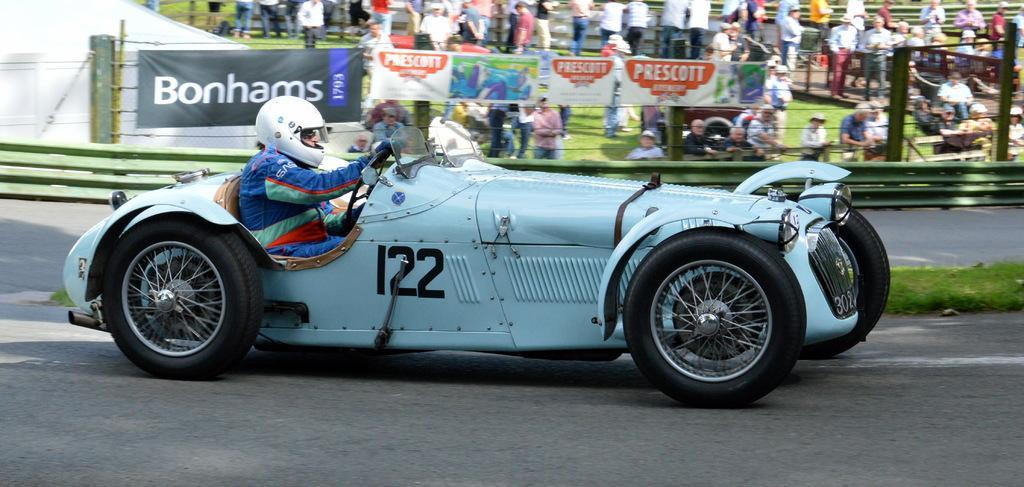Please provide a concise description of this image. In this image there is a man who is riding the racing car. In the background there is fence to which there are banners. Behind the fence there are so many spectators who are standing on the ground and watching the race. The man is wearing the helmet. 